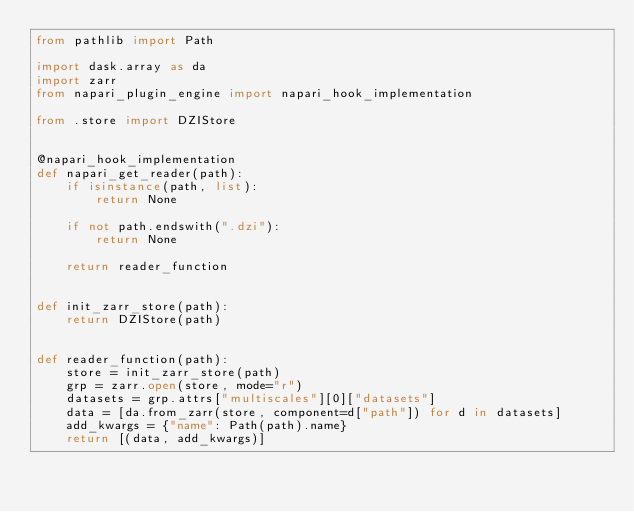Convert code to text. <code><loc_0><loc_0><loc_500><loc_500><_Python_>from pathlib import Path

import dask.array as da
import zarr
from napari_plugin_engine import napari_hook_implementation

from .store import DZIStore


@napari_hook_implementation
def napari_get_reader(path):
    if isinstance(path, list):
        return None

    if not path.endswith(".dzi"):
        return None

    return reader_function


def init_zarr_store(path):
    return DZIStore(path)


def reader_function(path):
    store = init_zarr_store(path)
    grp = zarr.open(store, mode="r")
    datasets = grp.attrs["multiscales"][0]["datasets"]
    data = [da.from_zarr(store, component=d["path"]) for d in datasets]
    add_kwargs = {"name": Path(path).name}
    return [(data, add_kwargs)]
</code> 